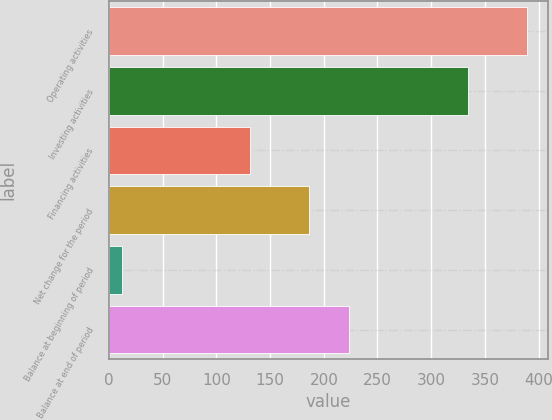Convert chart to OTSL. <chart><loc_0><loc_0><loc_500><loc_500><bar_chart><fcel>Operating activities<fcel>Investing activities<fcel>Financing activities<fcel>Net change for the period<fcel>Balance at beginning of period<fcel>Balance at end of period<nl><fcel>389<fcel>334<fcel>131<fcel>186<fcel>12<fcel>223.7<nl></chart> 